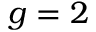Convert formula to latex. <formula><loc_0><loc_0><loc_500><loc_500>g = 2</formula> 